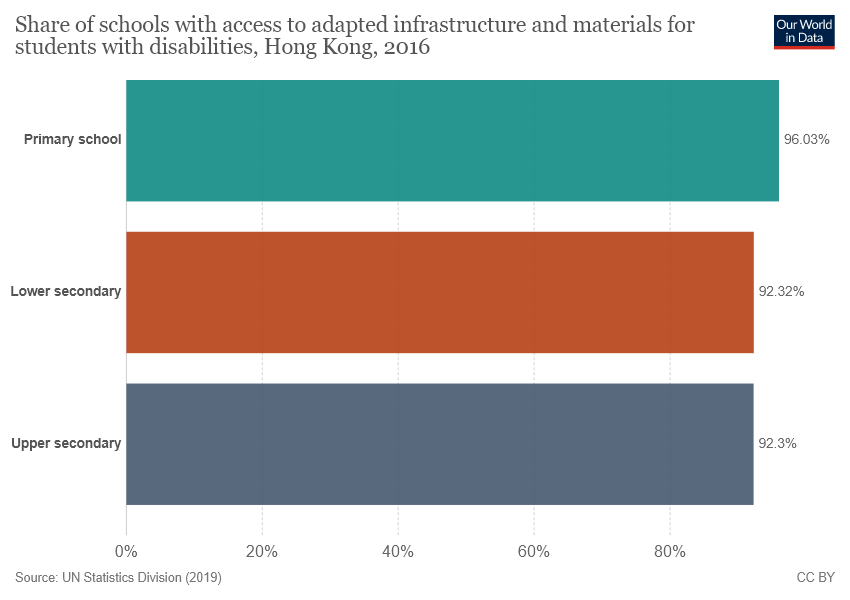Highlight a few significant elements in this photo. The color of value 96.03% is green. The difference between lower secondary and upper secondary bars is 0.02. 